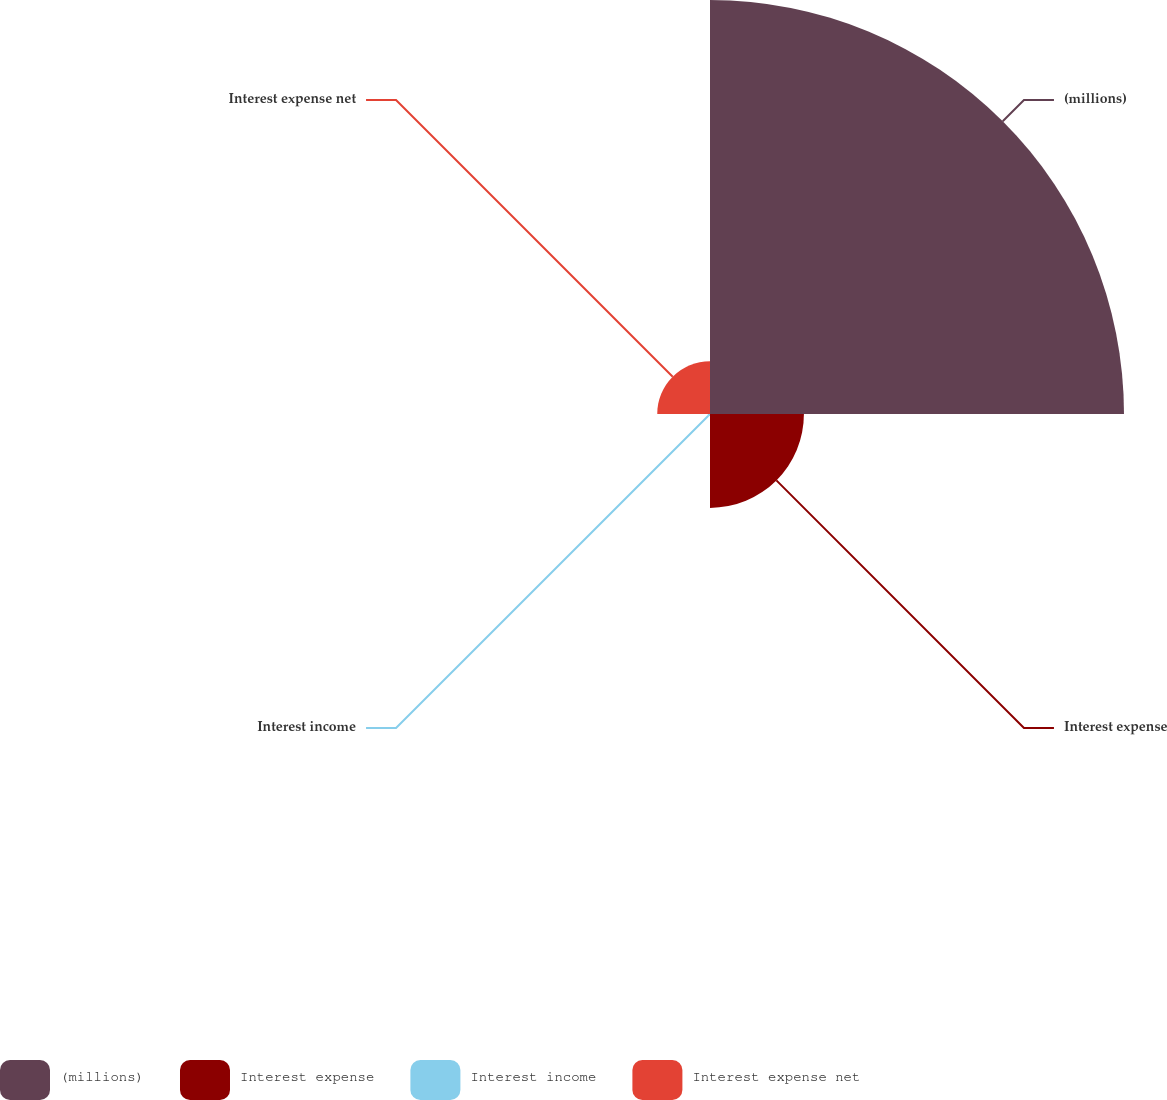<chart> <loc_0><loc_0><loc_500><loc_500><pie_chart><fcel>(millions)<fcel>Interest expense<fcel>Interest income<fcel>Interest expense net<nl><fcel>73.53%<fcel>16.68%<fcel>0.42%<fcel>9.37%<nl></chart> 